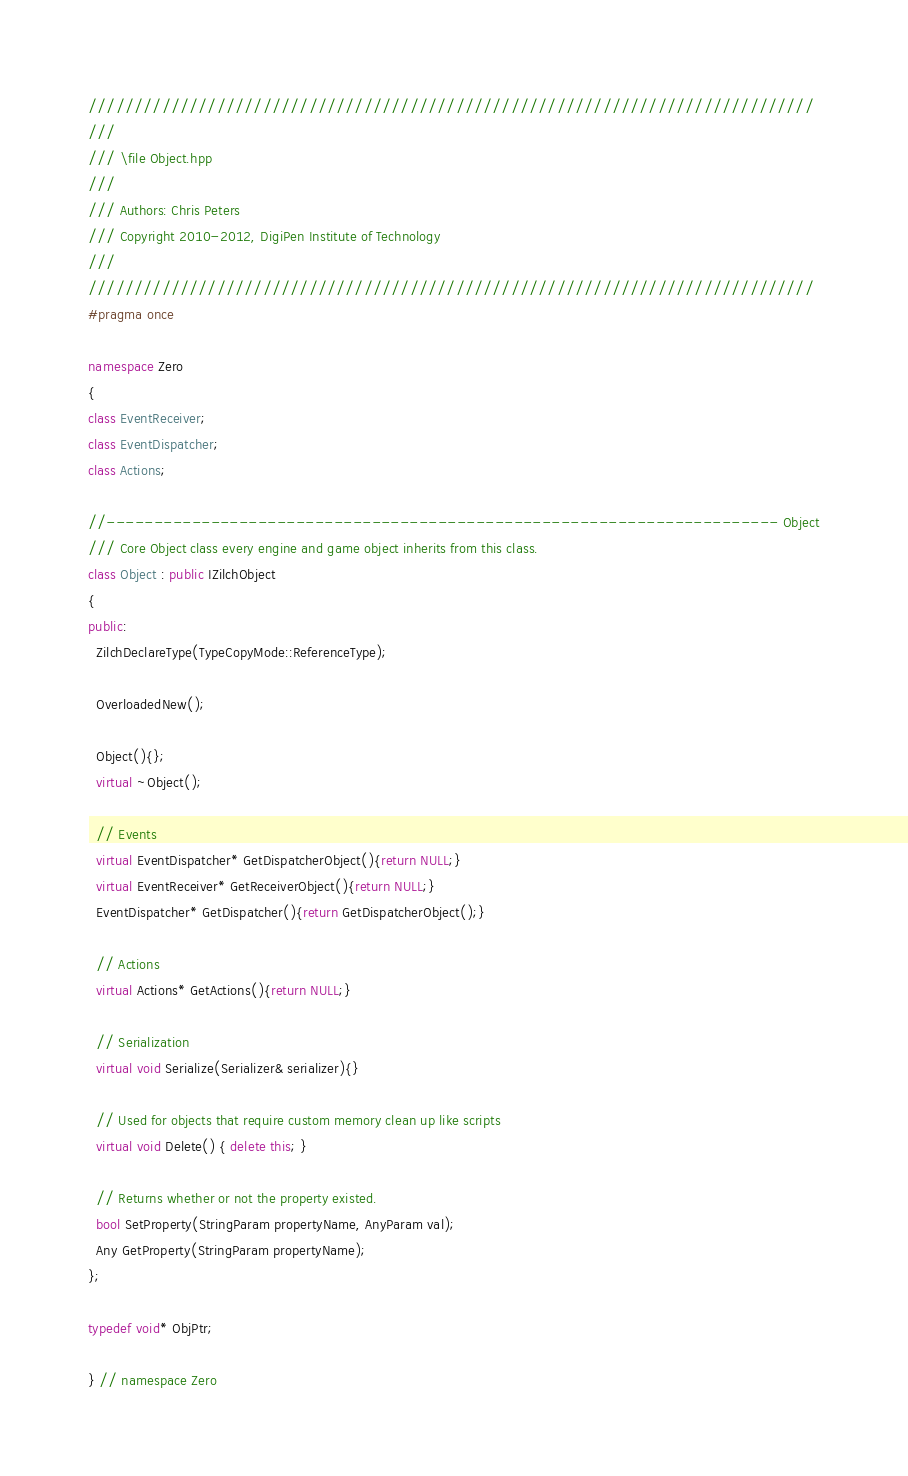Convert code to text. <code><loc_0><loc_0><loc_500><loc_500><_C++_>///////////////////////////////////////////////////////////////////////////////
///
/// \file Object.hpp
///
/// Authors: Chris Peters
/// Copyright 2010-2012, DigiPen Institute of Technology
///
///////////////////////////////////////////////////////////////////////////////
#pragma once

namespace Zero
{
class EventReceiver;
class EventDispatcher;
class Actions;

//----------------------------------------------------------------------- Object
/// Core Object class every engine and game object inherits from this class.
class Object : public IZilchObject
{
public:
  ZilchDeclareType(TypeCopyMode::ReferenceType);

  OverloadedNew();

  Object(){};
  virtual ~Object();

  // Events
  virtual EventDispatcher* GetDispatcherObject(){return NULL;}
  virtual EventReceiver* GetReceiverObject(){return NULL;}
  EventDispatcher* GetDispatcher(){return GetDispatcherObject();}

  // Actions
  virtual Actions* GetActions(){return NULL;}

  // Serialization
  virtual void Serialize(Serializer& serializer){}

  // Used for objects that require custom memory clean up like scripts
  virtual void Delete() { delete this; }

  // Returns whether or not the property existed.
  bool SetProperty(StringParam propertyName, AnyParam val);
  Any GetProperty(StringParam propertyName);
};

typedef void* ObjPtr;

} // namespace Zero
</code> 